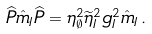Convert formula to latex. <formula><loc_0><loc_0><loc_500><loc_500>\widehat { P } \hat { m } _ { I } \widehat { P } = \eta _ { \emptyset } ^ { 2 } \widetilde { \eta } _ { I } ^ { 2 } g _ { I } ^ { 2 } \hat { m } _ { I } \, .</formula> 